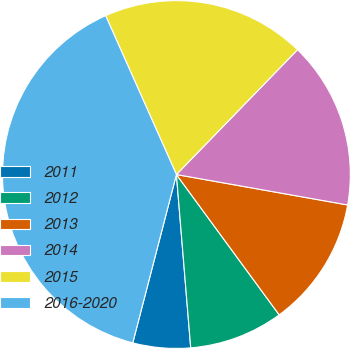Convert chart to OTSL. <chart><loc_0><loc_0><loc_500><loc_500><pie_chart><fcel>2011<fcel>2012<fcel>2013<fcel>2014<fcel>2015<fcel>2016-2020<nl><fcel>5.35%<fcel>8.75%<fcel>12.14%<fcel>15.54%<fcel>18.93%<fcel>39.29%<nl></chart> 